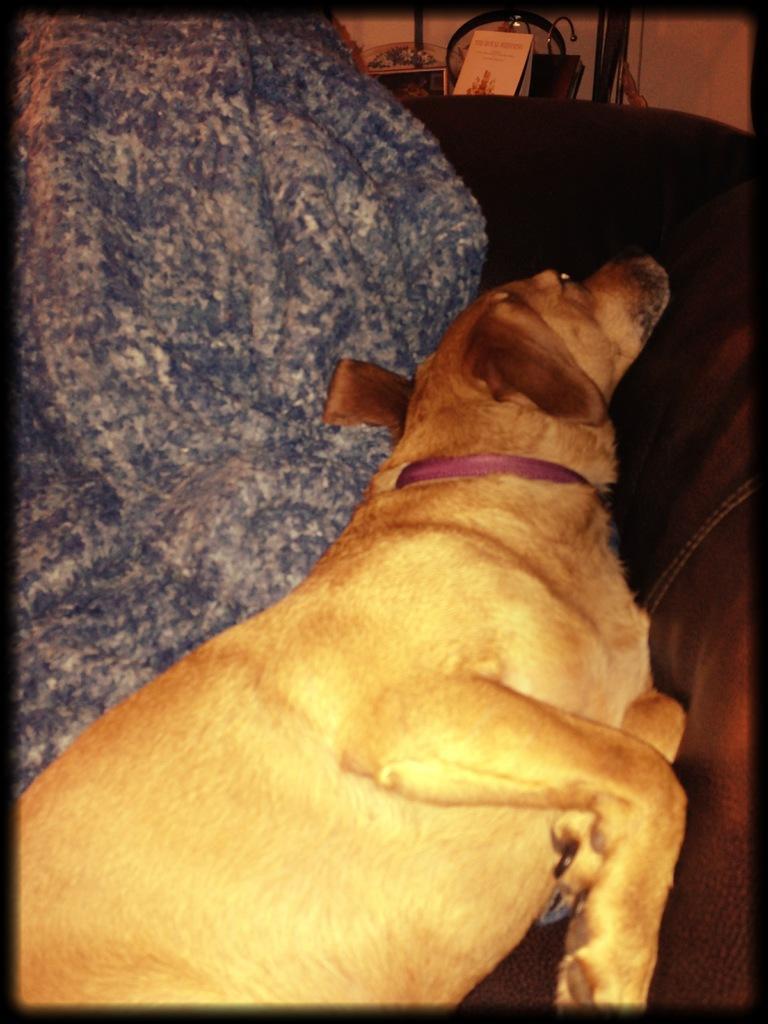How would you summarize this image in a sentence or two? In this picture we can see a dog. This is a belt. In the background we can see objects. 